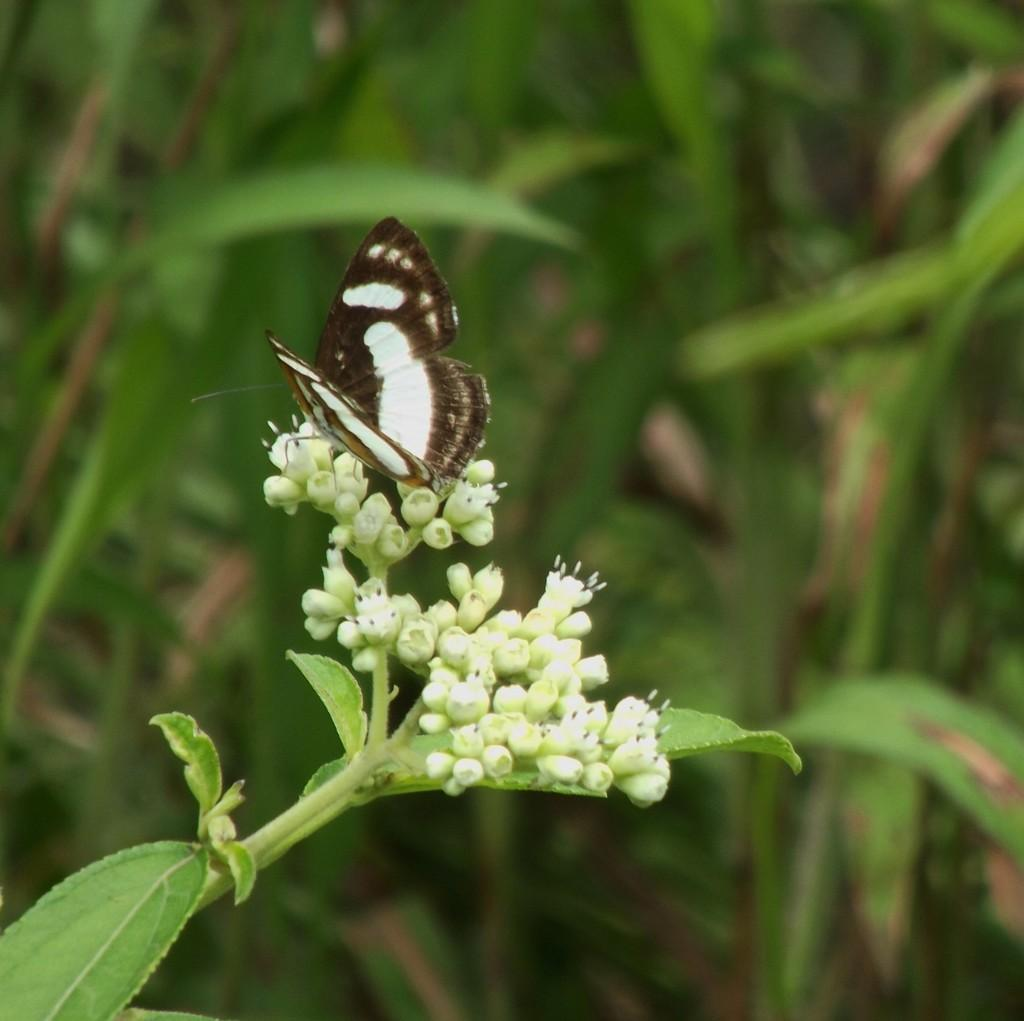What is the main subject of the image? The main subject of the image is a plant with many buds. How many plants can be seen in the image? There are multiple plants in the image. What is the appearance of the background in the image? The background of the image is blurred. Can you describe any additional elements in the image? Yes, there is a butterfly sitting on a bud in the image. What type of rhythm can be heard in the image? There is no sound or rhythm present in the image, as it is a still photograph of plants and a butterfly. 